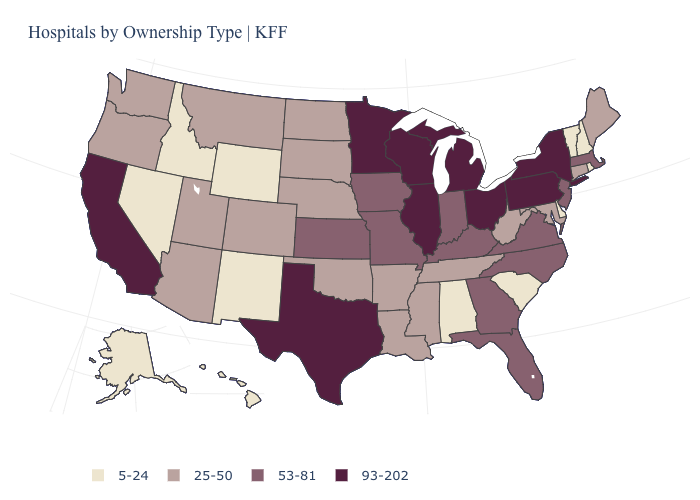Name the states that have a value in the range 5-24?
Answer briefly. Alabama, Alaska, Delaware, Hawaii, Idaho, Nevada, New Hampshire, New Mexico, Rhode Island, South Carolina, Vermont, Wyoming. What is the value of Maine?
Short answer required. 25-50. Does Pennsylvania have the highest value in the USA?
Write a very short answer. Yes. What is the value of Pennsylvania?
Be succinct. 93-202. Name the states that have a value in the range 53-81?
Quick response, please. Florida, Georgia, Indiana, Iowa, Kansas, Kentucky, Massachusetts, Missouri, New Jersey, North Carolina, Virginia. What is the highest value in states that border Louisiana?
Answer briefly. 93-202. Name the states that have a value in the range 53-81?
Write a very short answer. Florida, Georgia, Indiana, Iowa, Kansas, Kentucky, Massachusetts, Missouri, New Jersey, North Carolina, Virginia. What is the value of Kentucky?
Write a very short answer. 53-81. Name the states that have a value in the range 53-81?
Concise answer only. Florida, Georgia, Indiana, Iowa, Kansas, Kentucky, Massachusetts, Missouri, New Jersey, North Carolina, Virginia. What is the highest value in the USA?
Concise answer only. 93-202. Which states have the highest value in the USA?
Concise answer only. California, Illinois, Michigan, Minnesota, New York, Ohio, Pennsylvania, Texas, Wisconsin. What is the highest value in states that border New York?
Quick response, please. 93-202. Name the states that have a value in the range 25-50?
Answer briefly. Arizona, Arkansas, Colorado, Connecticut, Louisiana, Maine, Maryland, Mississippi, Montana, Nebraska, North Dakota, Oklahoma, Oregon, South Dakota, Tennessee, Utah, Washington, West Virginia. Among the states that border Rhode Island , which have the lowest value?
Quick response, please. Connecticut. 